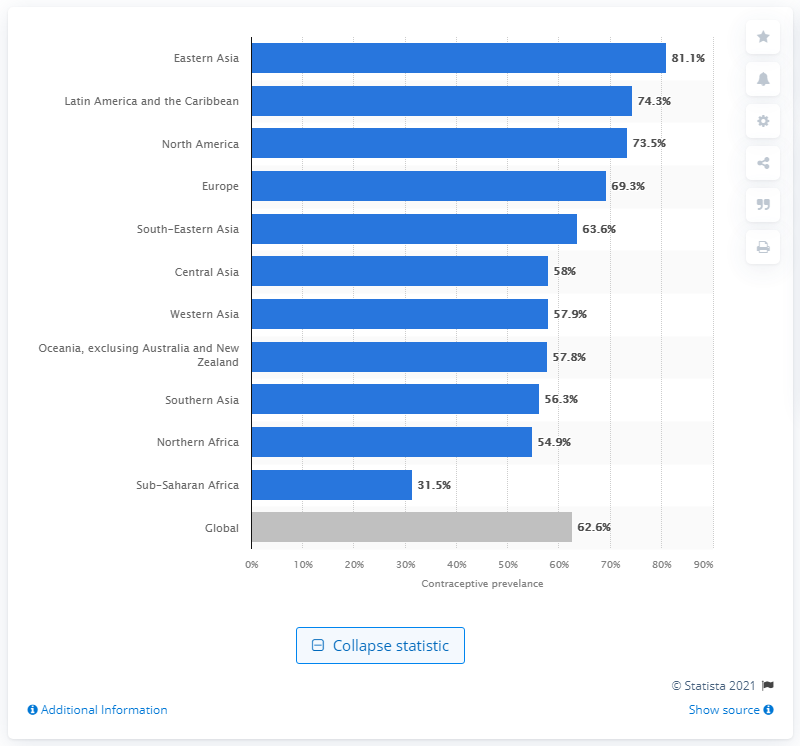Mention a couple of crucial points in this snapshot. The contraceptive prevalence in sub-Saharan Africa in 2018 was 31.5%. According to recent data, 31.5% of women in sub-Saharan Africa are currently using at least one method of contraception. 